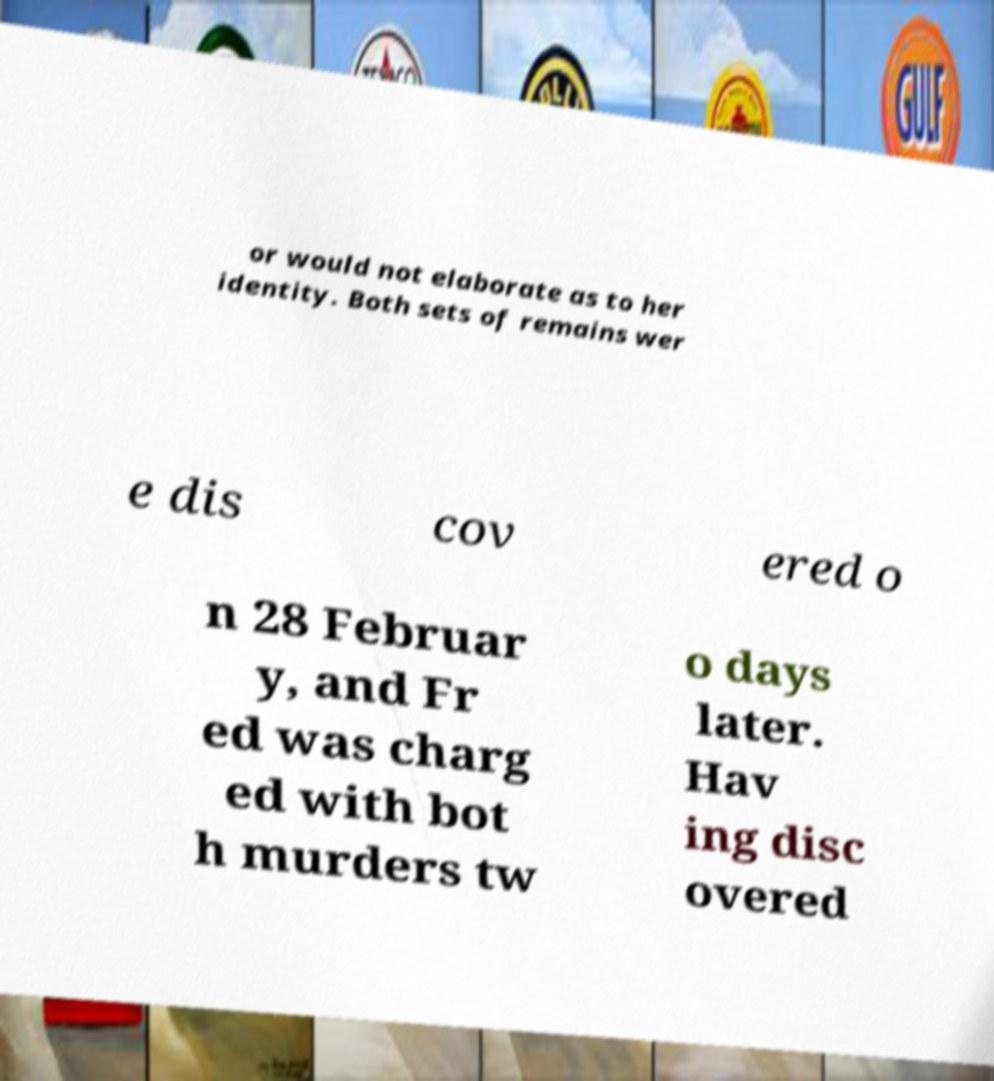Please identify and transcribe the text found in this image. or would not elaborate as to her identity. Both sets of remains wer e dis cov ered o n 28 Februar y, and Fr ed was charg ed with bot h murders tw o days later. Hav ing disc overed 